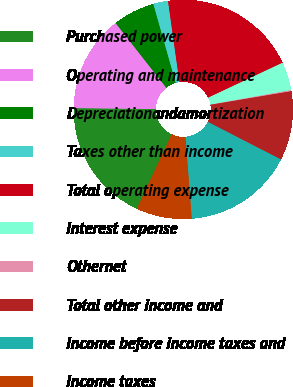<chart> <loc_0><loc_0><loc_500><loc_500><pie_chart><fcel>Purchased power<fcel>Operating and maintenance<fcel>Depreciationandamortization<fcel>Taxes other than income<fcel>Total operating expense<fcel>Interest expense<fcel>Othernet<fcel>Total other income and<fcel>Income before income taxes and<fcel>Income taxes<nl><fcel>18.23%<fcel>14.22%<fcel>6.19%<fcel>2.17%<fcel>20.24%<fcel>4.18%<fcel>0.16%<fcel>10.2%<fcel>16.22%<fcel>8.19%<nl></chart> 